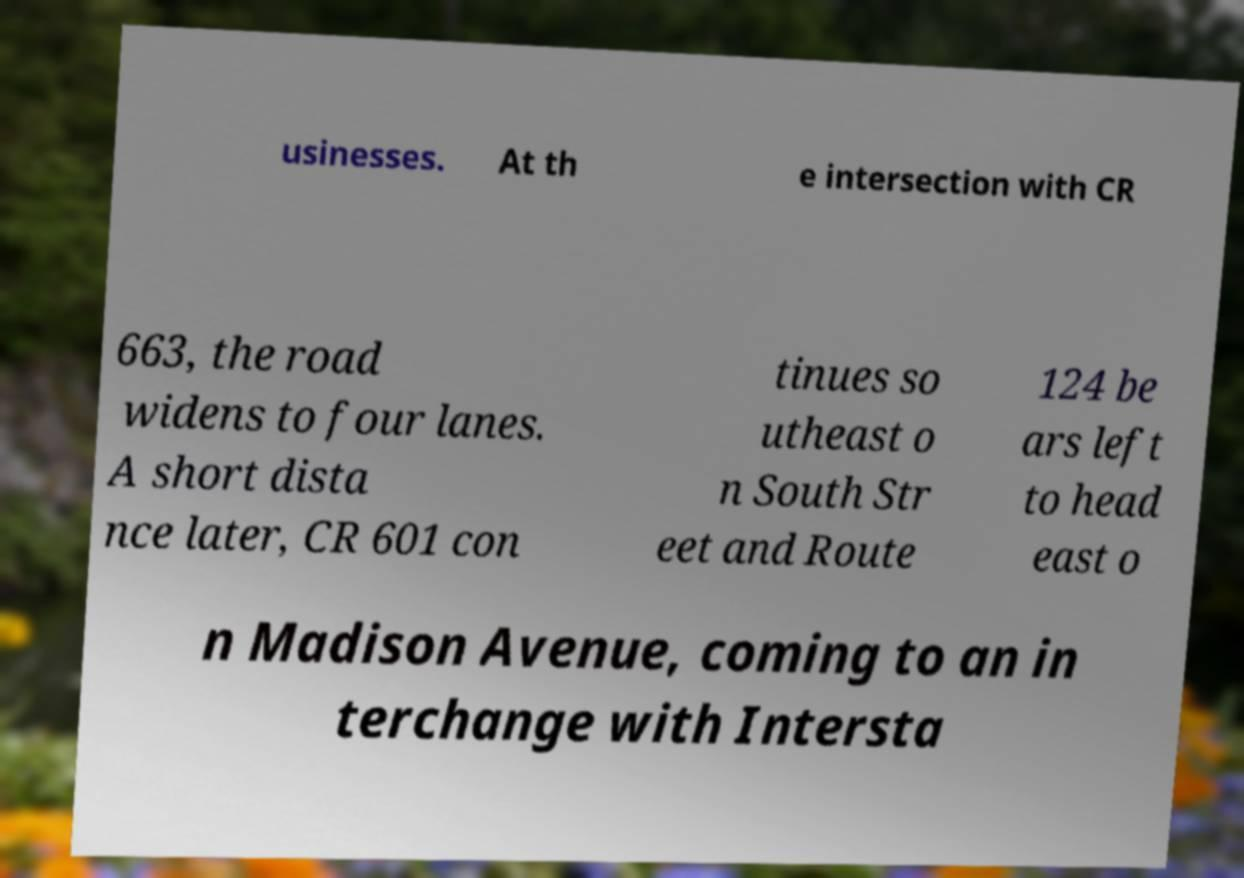For documentation purposes, I need the text within this image transcribed. Could you provide that? usinesses. At th e intersection with CR 663, the road widens to four lanes. A short dista nce later, CR 601 con tinues so utheast o n South Str eet and Route 124 be ars left to head east o n Madison Avenue, coming to an in terchange with Intersta 